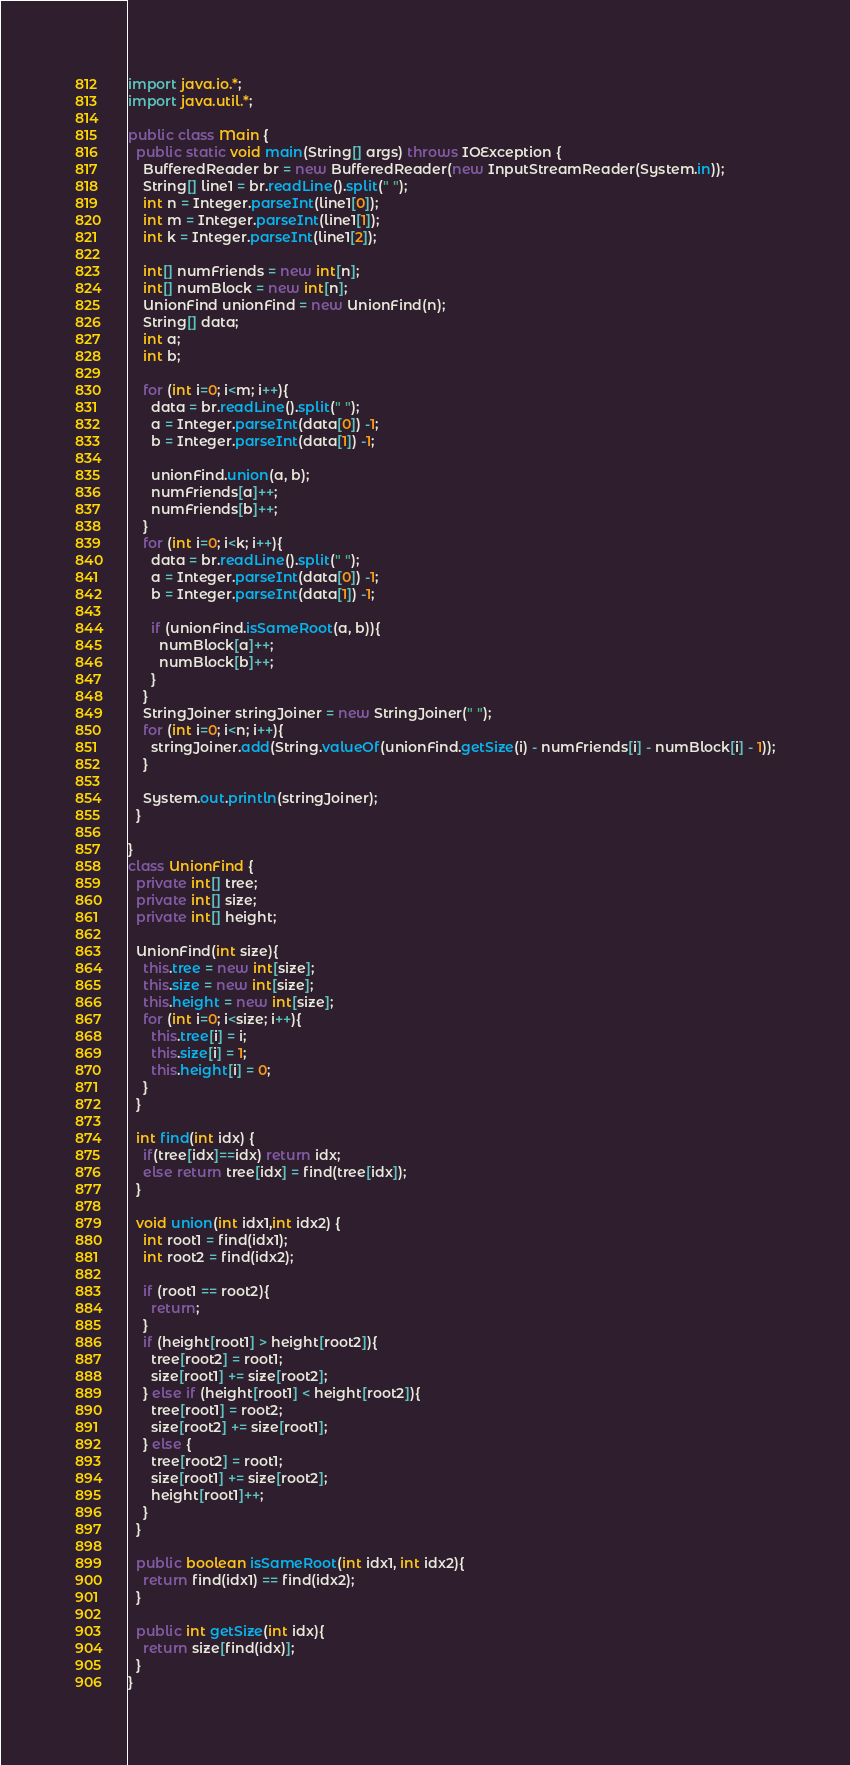<code> <loc_0><loc_0><loc_500><loc_500><_Java_>import java.io.*;
import java.util.*;

public class Main {
  public static void main(String[] args) throws IOException {
    BufferedReader br = new BufferedReader(new InputStreamReader(System.in));
    String[] line1 = br.readLine().split(" ");
    int n = Integer.parseInt(line1[0]);
    int m = Integer.parseInt(line1[1]);
    int k = Integer.parseInt(line1[2]);
  
    int[] numFriends = new int[n];
    int[] numBlock = new int[n];
    UnionFind unionFind = new UnionFind(n);
    String[] data;
    int a;
    int b;
    
    for (int i=0; i<m; i++){
      data = br.readLine().split(" ");
      a = Integer.parseInt(data[0]) -1;
      b = Integer.parseInt(data[1]) -1;
      
      unionFind.union(a, b);
      numFriends[a]++;
      numFriends[b]++;
    }
    for (int i=0; i<k; i++){
      data = br.readLine().split(" ");
      a = Integer.parseInt(data[0]) -1;
      b = Integer.parseInt(data[1]) -1;
      
      if (unionFind.isSameRoot(a, b)){
        numBlock[a]++;
        numBlock[b]++;
      }
    }
    StringJoiner stringJoiner = new StringJoiner(" ");
    for (int i=0; i<n; i++){
      stringJoiner.add(String.valueOf(unionFind.getSize(i) - numFriends[i] - numBlock[i] - 1));
    }
    
    System.out.println(stringJoiner);
  }
  
}
class UnionFind {
  private int[] tree;
  private int[] size;
  private int[] height;
  
  UnionFind(int size){
    this.tree = new int[size];
    this.size = new int[size];
    this.height = new int[size];
    for (int i=0; i<size; i++){
      this.tree[i] = i;
      this.size[i] = 1;
      this.height[i] = 0;
    }
  }
  
  int find(int idx) {
    if(tree[idx]==idx) return idx;
    else return tree[idx] = find(tree[idx]);
  }
  
  void union(int idx1,int idx2) {
    int root1 = find(idx1);
    int root2 = find(idx2);
    
    if (root1 == root2){
      return;
    }
    if (height[root1] > height[root2]){
      tree[root2] = root1;
      size[root1] += size[root2];
    } else if (height[root1] < height[root2]){
      tree[root1] = root2;
      size[root2] += size[root1];
    } else {
      tree[root2] = root1;
      size[root1] += size[root2];
      height[root1]++;
    }
  }
  
  public boolean isSameRoot(int idx1, int idx2){
    return find(idx1) == find(idx2);
  }
  
  public int getSize(int idx){
    return size[find(idx)];
  }
}
</code> 